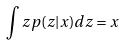<formula> <loc_0><loc_0><loc_500><loc_500>\int z p ( z | x ) d z = x</formula> 